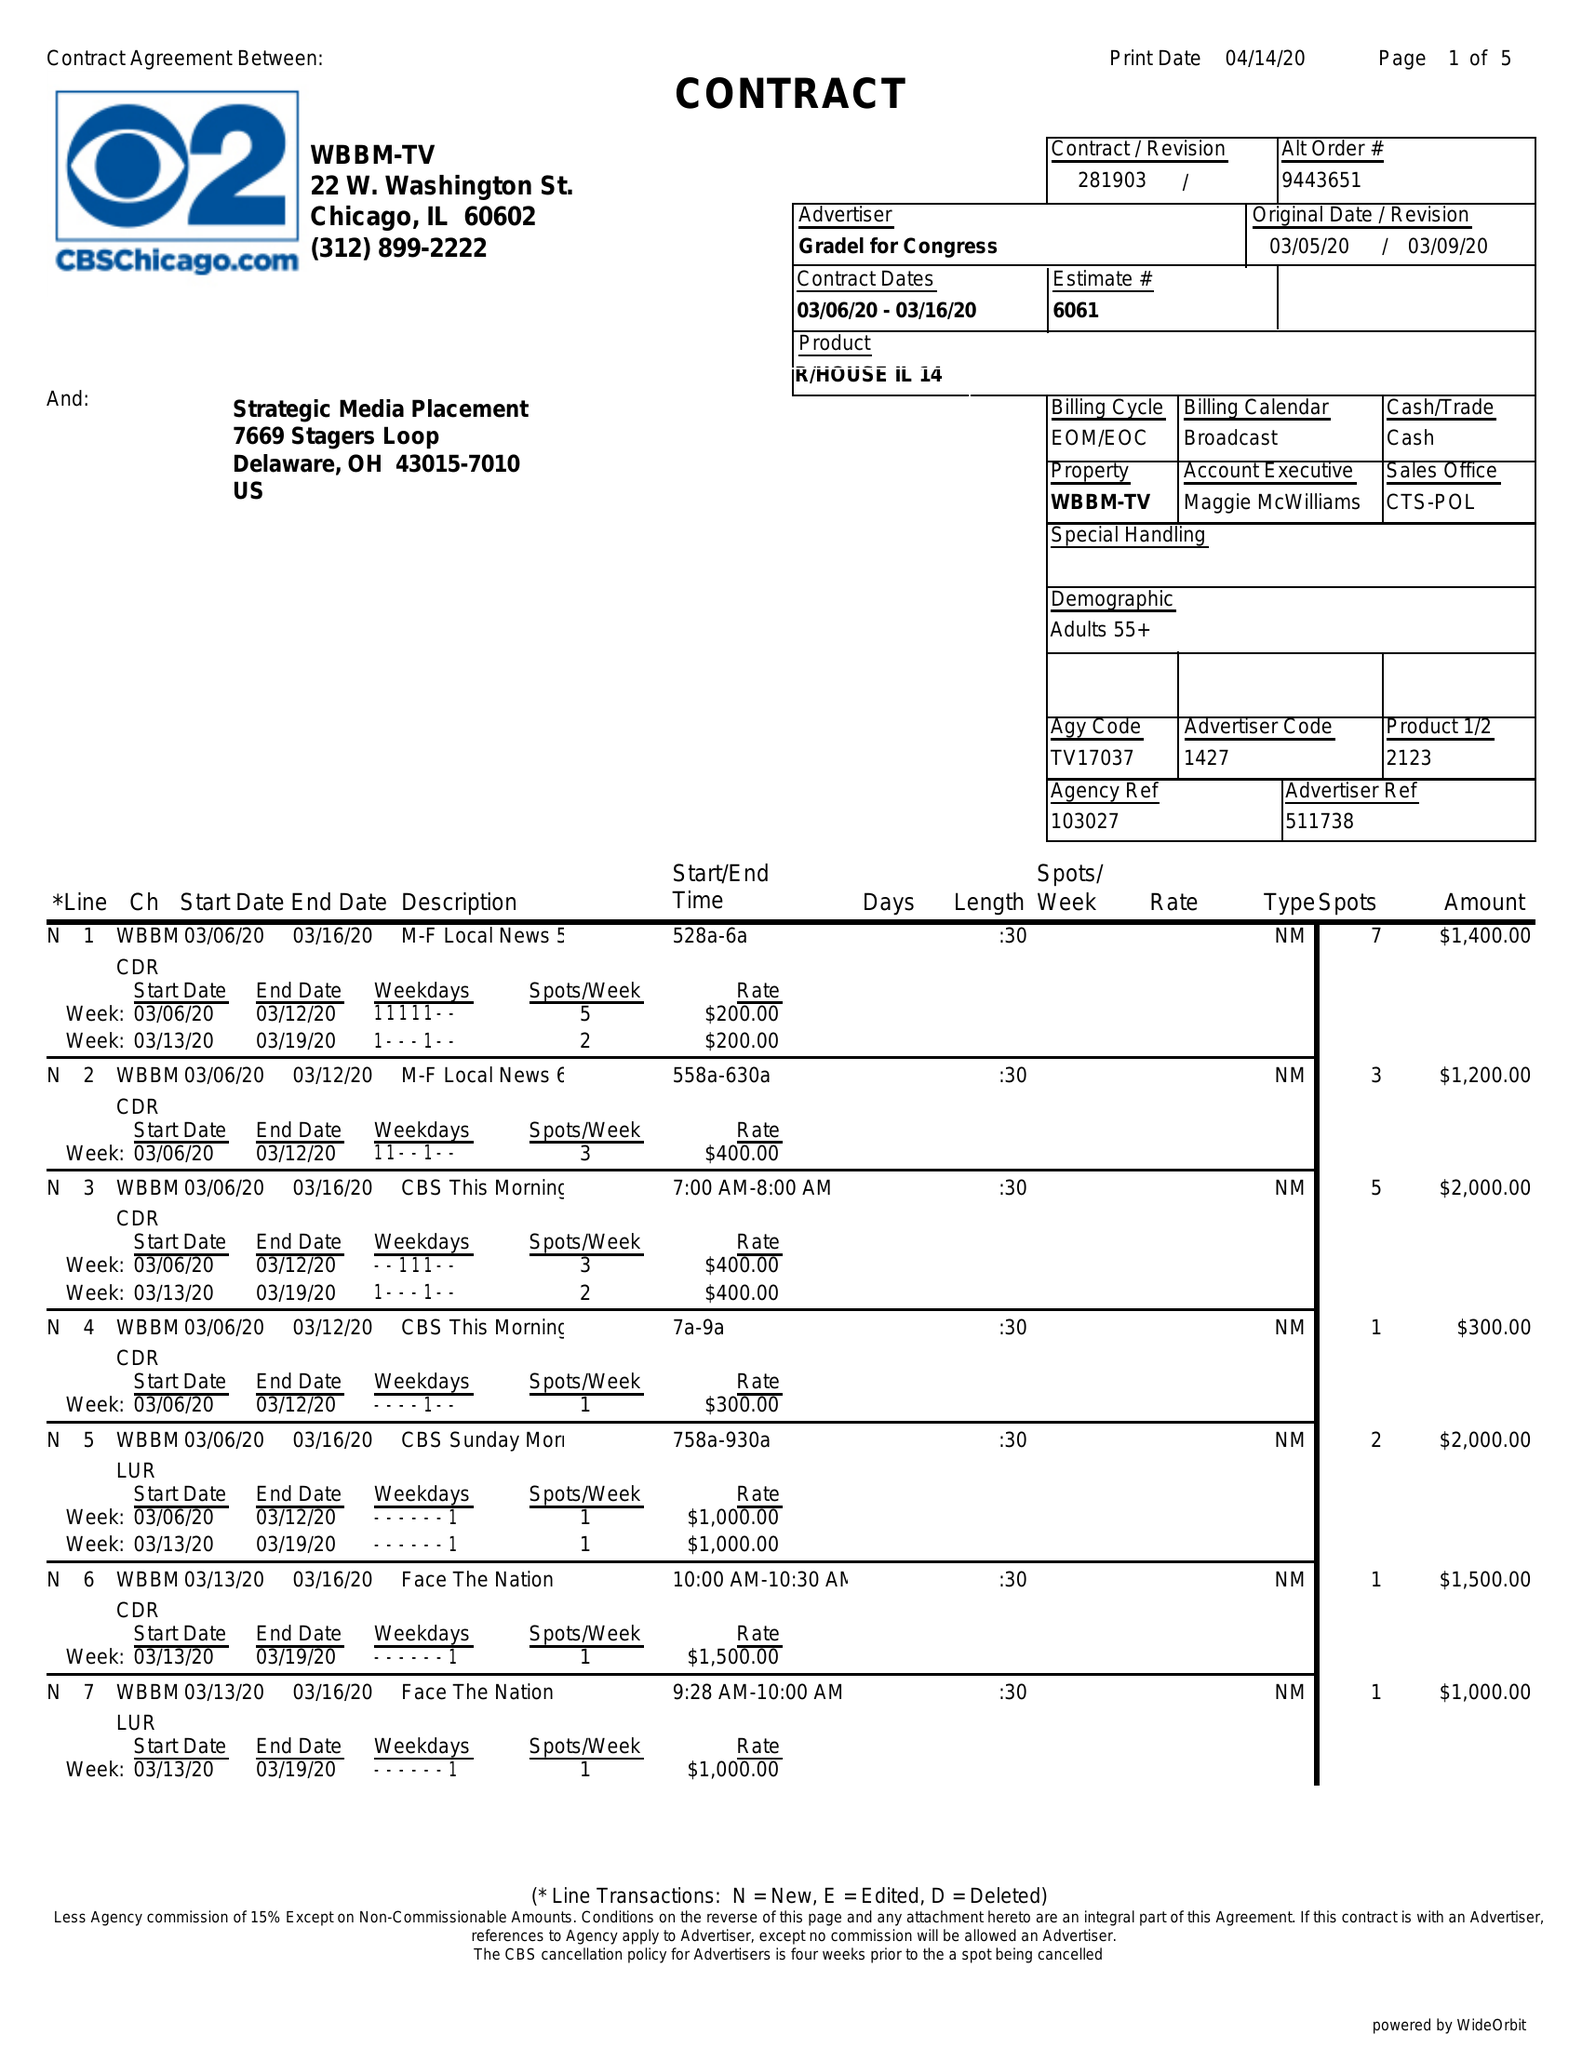What is the value for the contract_num?
Answer the question using a single word or phrase. 281903 